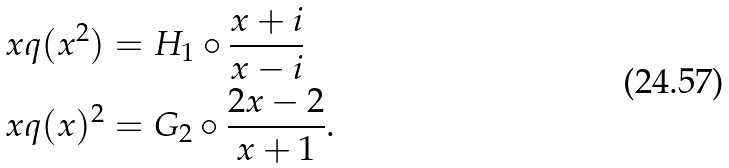Convert formula to latex. <formula><loc_0><loc_0><loc_500><loc_500>x q ( x ^ { 2 } ) & = H _ { 1 } \circ \frac { x + i } { x - i } \\ x q ( x ) ^ { 2 } & = G _ { 2 } \circ \frac { 2 x - 2 } { x + 1 } .</formula> 